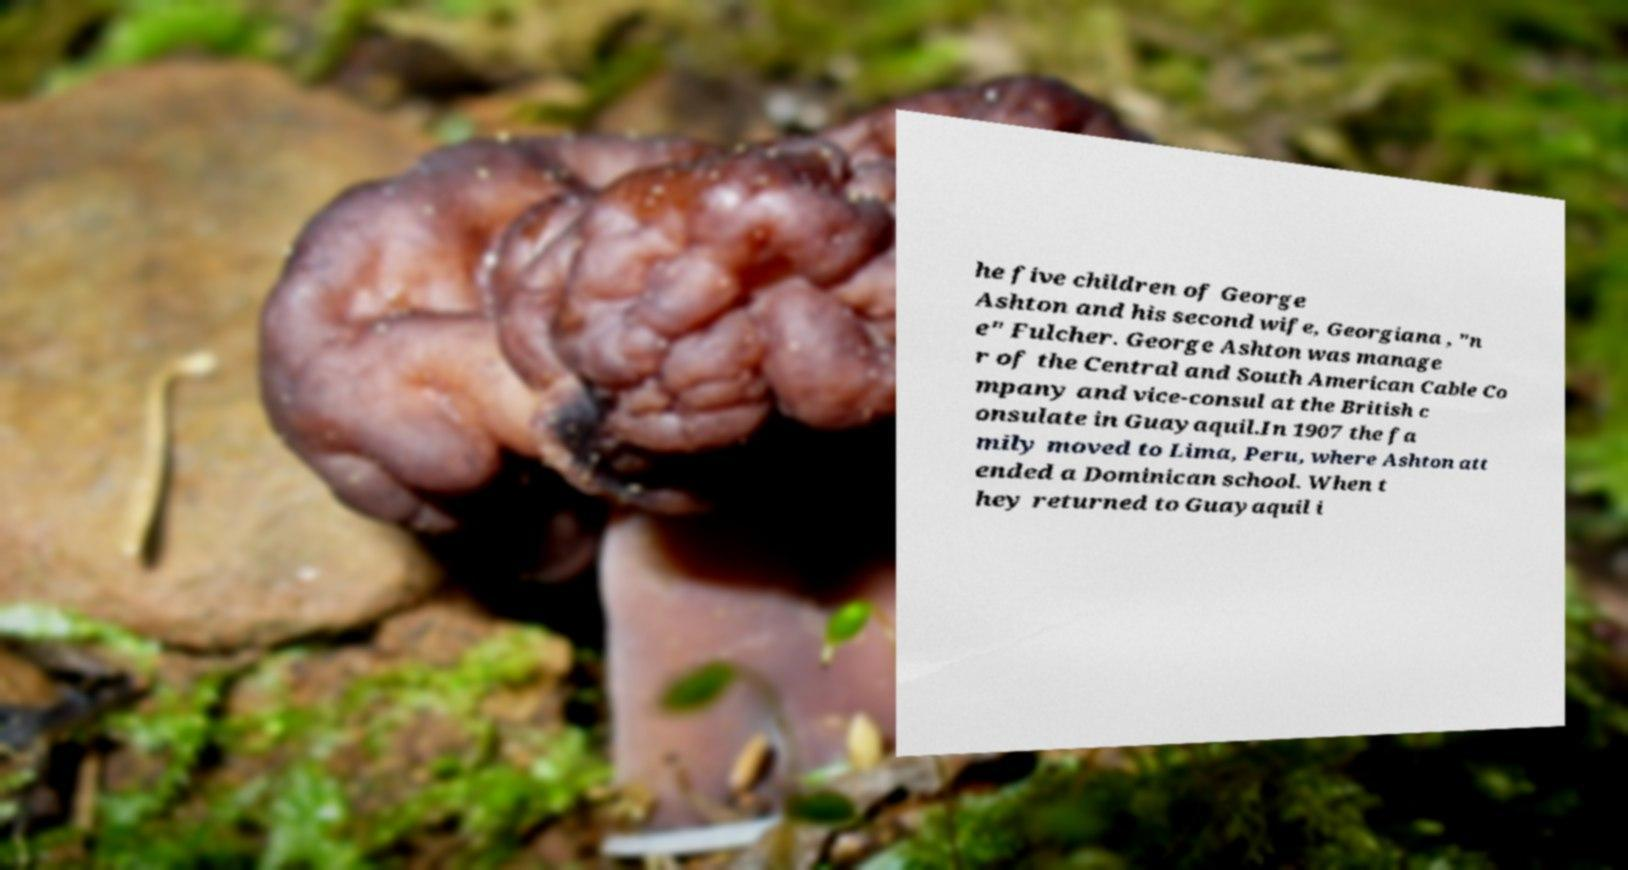Can you read and provide the text displayed in the image?This photo seems to have some interesting text. Can you extract and type it out for me? he five children of George Ashton and his second wife, Georgiana , "n e" Fulcher. George Ashton was manage r of the Central and South American Cable Co mpany and vice-consul at the British c onsulate in Guayaquil.In 1907 the fa mily moved to Lima, Peru, where Ashton att ended a Dominican school. When t hey returned to Guayaquil i 